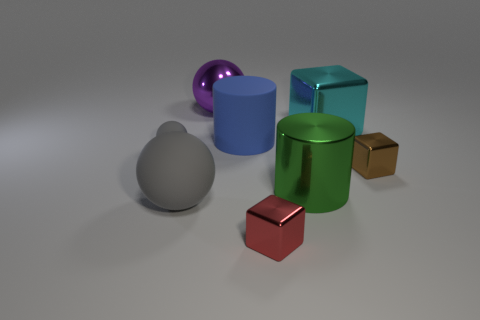There is a tiny gray object; how many big blue rubber cylinders are left of it?
Make the answer very short. 0. There is a object that is both right of the metal sphere and in front of the green metal cylinder; what material is it?
Provide a short and direct response. Metal. What number of big things are either cylinders or red things?
Your answer should be compact. 2. How big is the blue rubber thing?
Keep it short and to the point. Large. The small gray object is what shape?
Your answer should be compact. Sphere. Is there anything else that is the same shape as the purple shiny object?
Your response must be concise. Yes. Is the number of cyan metallic blocks right of the tiny red object less than the number of brown things?
Your answer should be very brief. No. Do the small shiny block to the right of the cyan metal object and the large matte cylinder have the same color?
Make the answer very short. No. How many rubber things are either brown objects or big blue objects?
Ensure brevity in your answer.  1. Is there anything else that is the same size as the cyan shiny thing?
Ensure brevity in your answer.  Yes. 